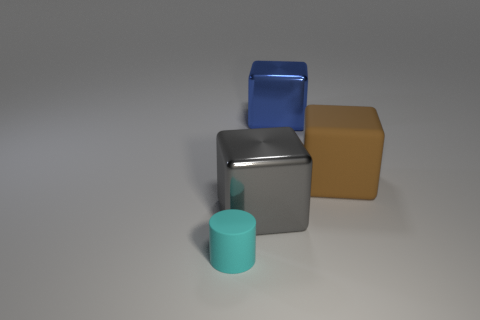Add 3 gray objects. How many objects exist? 7 Subtract all big metal cubes. How many cubes are left? 1 Subtract all brown cubes. How many cubes are left? 2 Subtract all blocks. How many objects are left? 1 Subtract 1 cylinders. How many cylinders are left? 0 Subtract all yellow cubes. Subtract all blue cylinders. How many cubes are left? 3 Subtract all green cylinders. How many green cubes are left? 0 Subtract all gray metallic cubes. Subtract all small purple matte spheres. How many objects are left? 3 Add 1 gray cubes. How many gray cubes are left? 2 Add 4 large green matte objects. How many large green matte objects exist? 4 